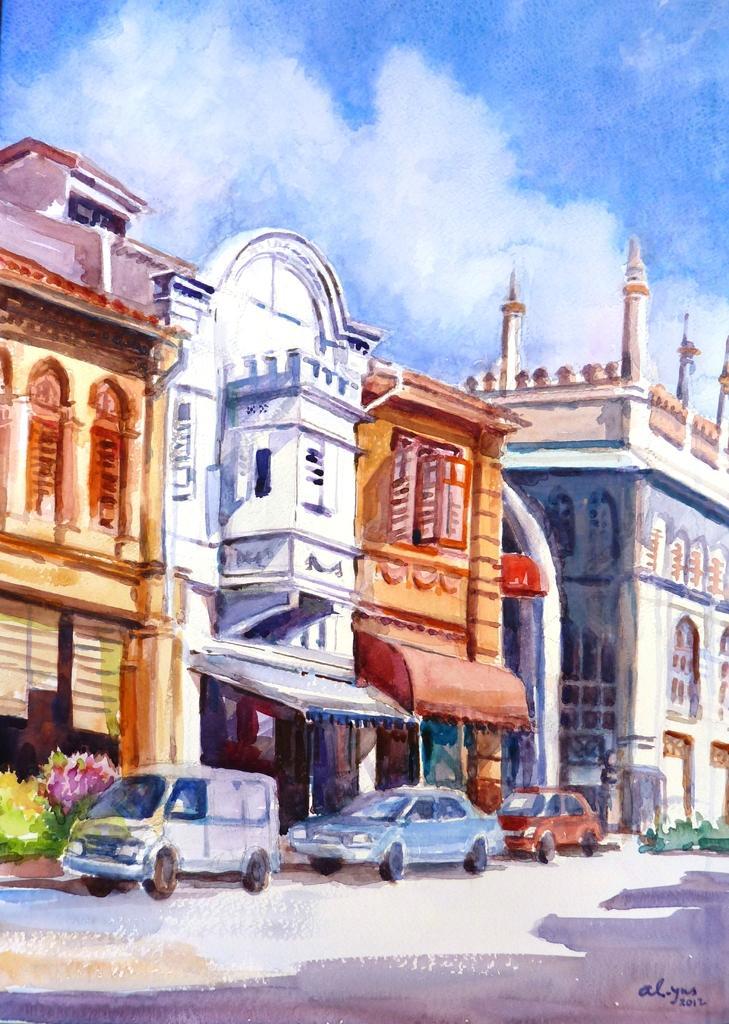In one or two sentences, can you explain what this image depicts? This image is a painting. In this image there are buildings and we can see cars. There are bushes. In the background we can see the sky. 